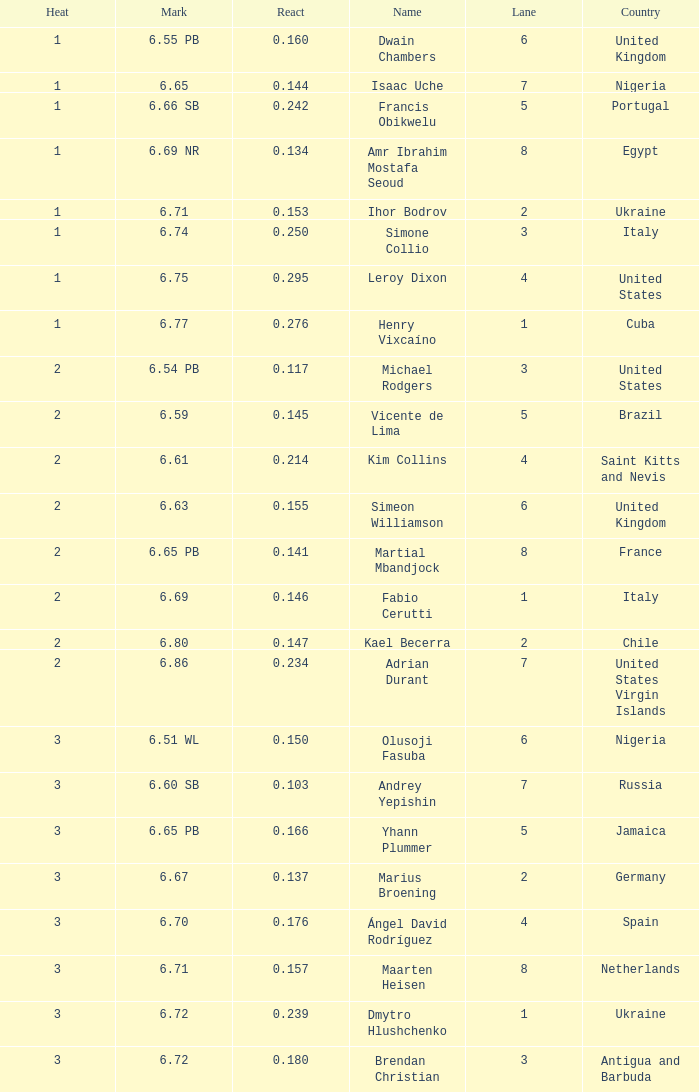What is Heat, when Mark is 6.69? 2.0. 